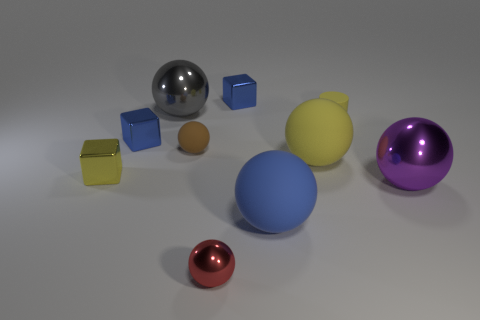What is the size of the rubber object that is the same color as the tiny cylinder?
Provide a short and direct response. Large. There is a small object that is the same color as the small matte cylinder; what material is it?
Make the answer very short. Metal. Are there the same number of large gray spheres that are behind the tiny rubber cylinder and small yellow metallic things that are in front of the blue ball?
Your answer should be very brief. No. There is a metal thing that is right of the large rubber ball in front of the yellow metal cube; what shape is it?
Offer a very short reply. Sphere. Is there a brown thing that has the same shape as the purple shiny thing?
Make the answer very short. Yes. How many small gray shiny blocks are there?
Your answer should be compact. 0. Does the tiny yellow object right of the blue ball have the same material as the big yellow thing?
Keep it short and to the point. Yes. Is there a matte cylinder of the same size as the brown ball?
Make the answer very short. Yes. There is a gray metallic thing; is its shape the same as the matte object that is to the left of the red ball?
Give a very brief answer. Yes. Is there a gray metallic sphere right of the blue shiny block to the right of the tiny object that is in front of the purple thing?
Provide a short and direct response. No. 